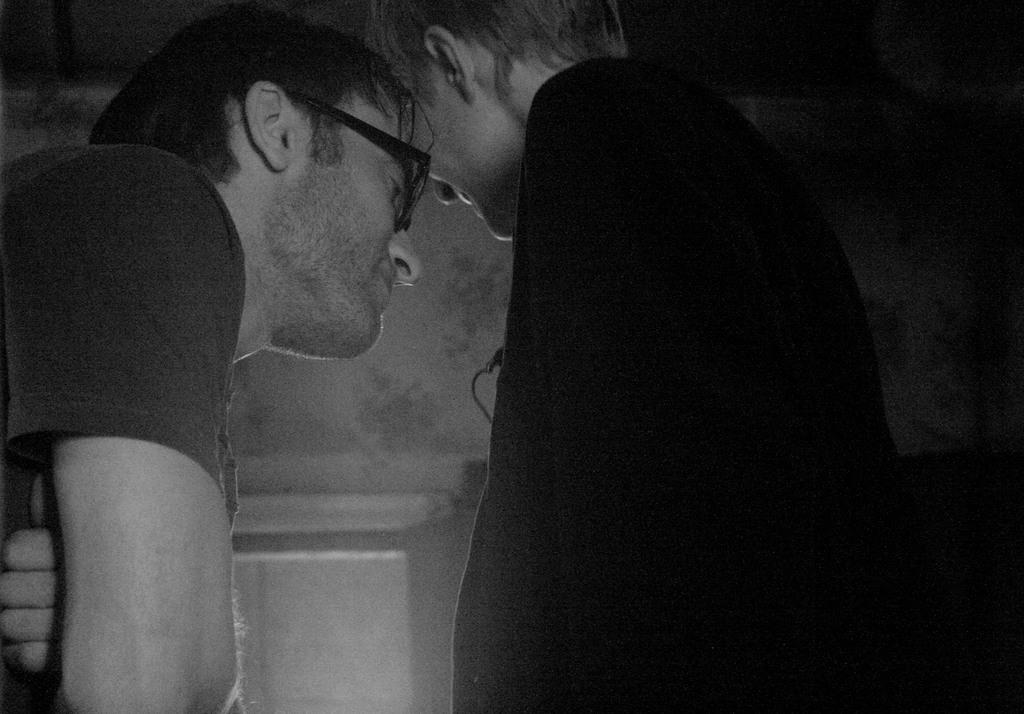How many people are in the image? There are two persons standing in the image. Can you describe the appearance of the person on the left? The person on the left is wearing spectacles. What is the color scheme of the image? The image is in black and white. What type of bell can be heard ringing in the image? There is no bell present in the image, and therefore no sound can be heard. What kind of stone is visible in the image? There is no stone visible in the image. 